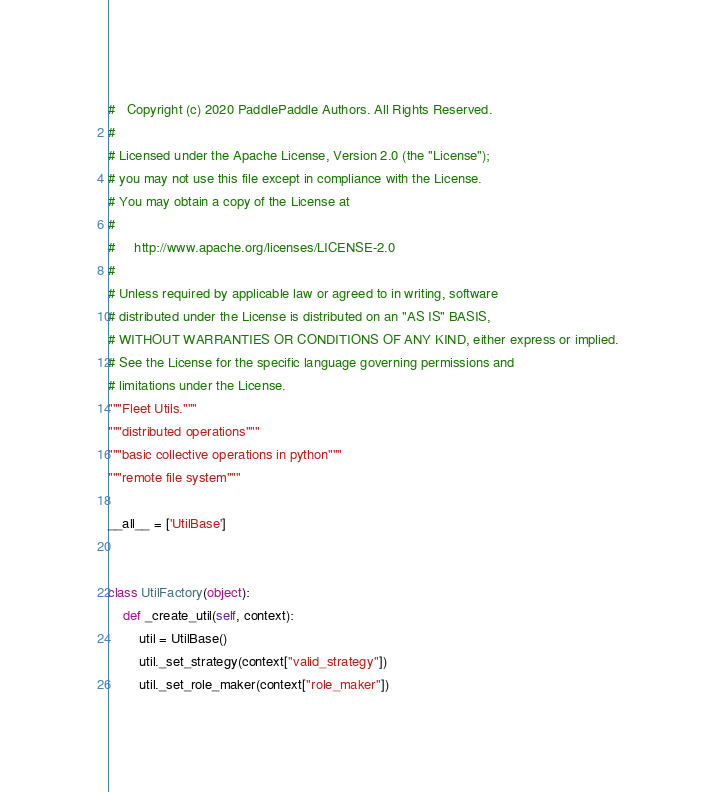<code> <loc_0><loc_0><loc_500><loc_500><_Python_>#   Copyright (c) 2020 PaddlePaddle Authors. All Rights Reserved.
#
# Licensed under the Apache License, Version 2.0 (the "License");
# you may not use this file except in compliance with the License.
# You may obtain a copy of the License at
#
#     http://www.apache.org/licenses/LICENSE-2.0
#
# Unless required by applicable law or agreed to in writing, software
# distributed under the License is distributed on an "AS IS" BASIS,
# WITHOUT WARRANTIES OR CONDITIONS OF ANY KIND, either express or implied.
# See the License for the specific language governing permissions and
# limitations under the License.
"""Fleet Utils."""
"""distributed operations"""
"""basic collective operations in python"""
"""remote file system"""

__all__ = ['UtilBase']


class UtilFactory(object):
    def _create_util(self, context):
        util = UtilBase()
        util._set_strategy(context["valid_strategy"])
        util._set_role_maker(context["role_maker"])</code> 